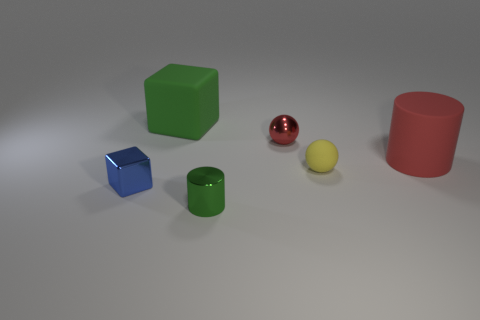Is there a purple rubber thing that has the same shape as the tiny yellow matte thing?
Keep it short and to the point. No. What shape is the object that is the same size as the red cylinder?
Provide a short and direct response. Cube. There is a red thing that is to the right of the tiny sphere that is left of the ball in front of the tiny shiny sphere; what is its material?
Make the answer very short. Rubber. Is the yellow sphere the same size as the green matte block?
Give a very brief answer. No. What is the tiny blue thing made of?
Your response must be concise. Metal. There is a large cube that is the same color as the metallic cylinder; what is its material?
Make the answer very short. Rubber. There is a thing left of the rubber cube; is it the same shape as the small green metallic thing?
Offer a terse response. No. What number of things are either big cylinders or small cyan shiny spheres?
Provide a short and direct response. 1. Do the large object that is behind the tiny red ball and the small blue cube have the same material?
Make the answer very short. No. The green matte thing has what size?
Provide a succinct answer. Large. 